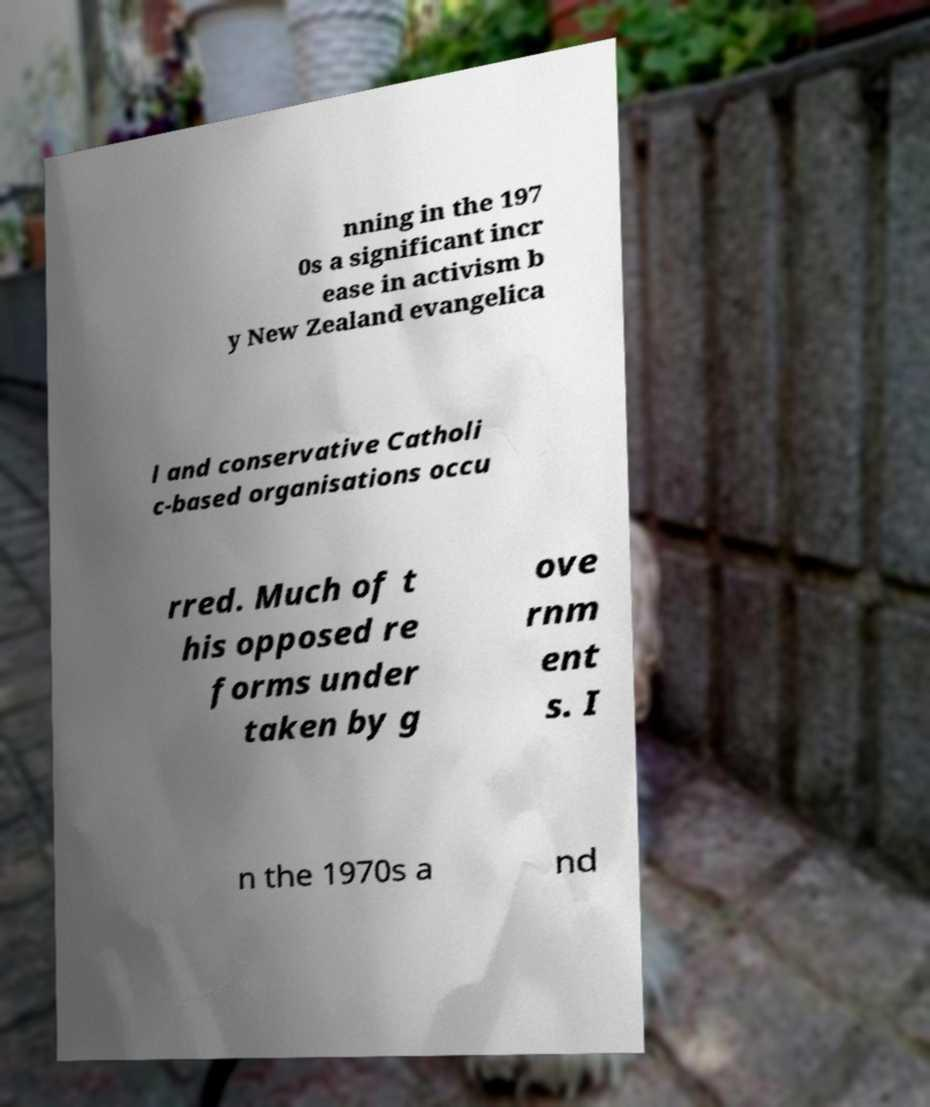Can you accurately transcribe the text from the provided image for me? nning in the 197 0s a significant incr ease in activism b y New Zealand evangelica l and conservative Catholi c-based organisations occu rred. Much of t his opposed re forms under taken by g ove rnm ent s. I n the 1970s a nd 